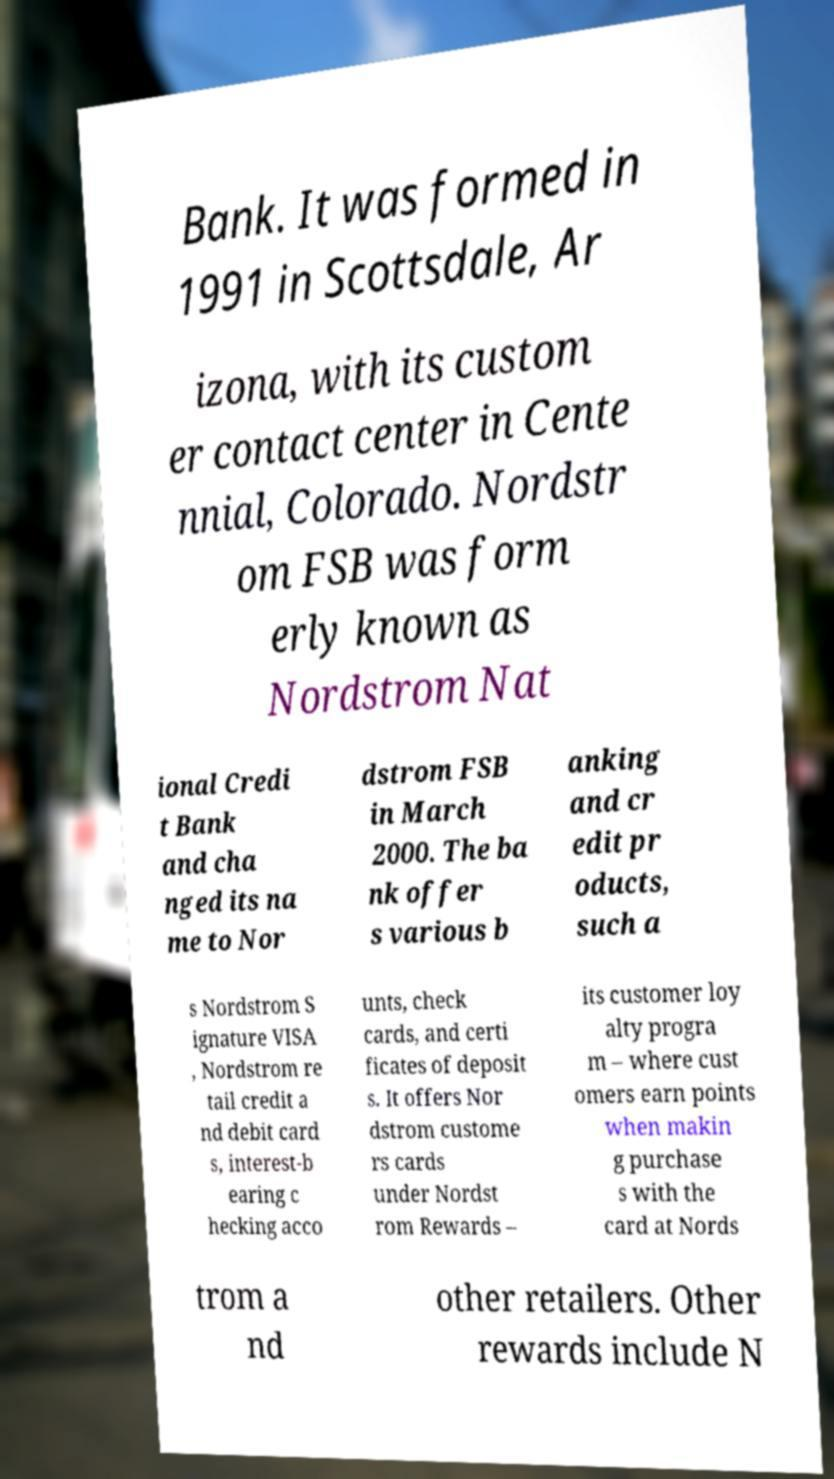What messages or text are displayed in this image? I need them in a readable, typed format. Bank. It was formed in 1991 in Scottsdale, Ar izona, with its custom er contact center in Cente nnial, Colorado. Nordstr om FSB was form erly known as Nordstrom Nat ional Credi t Bank and cha nged its na me to Nor dstrom FSB in March 2000. The ba nk offer s various b anking and cr edit pr oducts, such a s Nordstrom S ignature VISA , Nordstrom re tail credit a nd debit card s, interest-b earing c hecking acco unts, check cards, and certi ficates of deposit s. It offers Nor dstrom custome rs cards under Nordst rom Rewards – its customer loy alty progra m – where cust omers earn points when makin g purchase s with the card at Nords trom a nd other retailers. Other rewards include N 